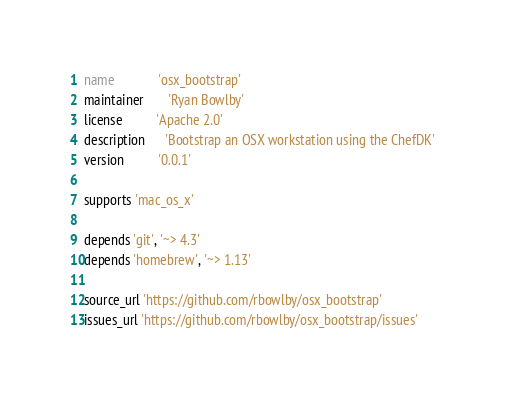Convert code to text. <code><loc_0><loc_0><loc_500><loc_500><_Ruby_>name             'osx_bootstrap'
maintainer       'Ryan Bowlby'
license          'Apache 2.0'
description      'Bootstrap an OSX workstation using the ChefDK'
version          '0.0.1'

supports 'mac_os_x'

depends 'git', '~> 4.3'
depends 'homebrew', '~> 1.13'

source_url 'https://github.com/rbowlby/osx_bootstrap'
issues_url 'https://github.com/rbowlby/osx_bootstrap/issues'
</code> 